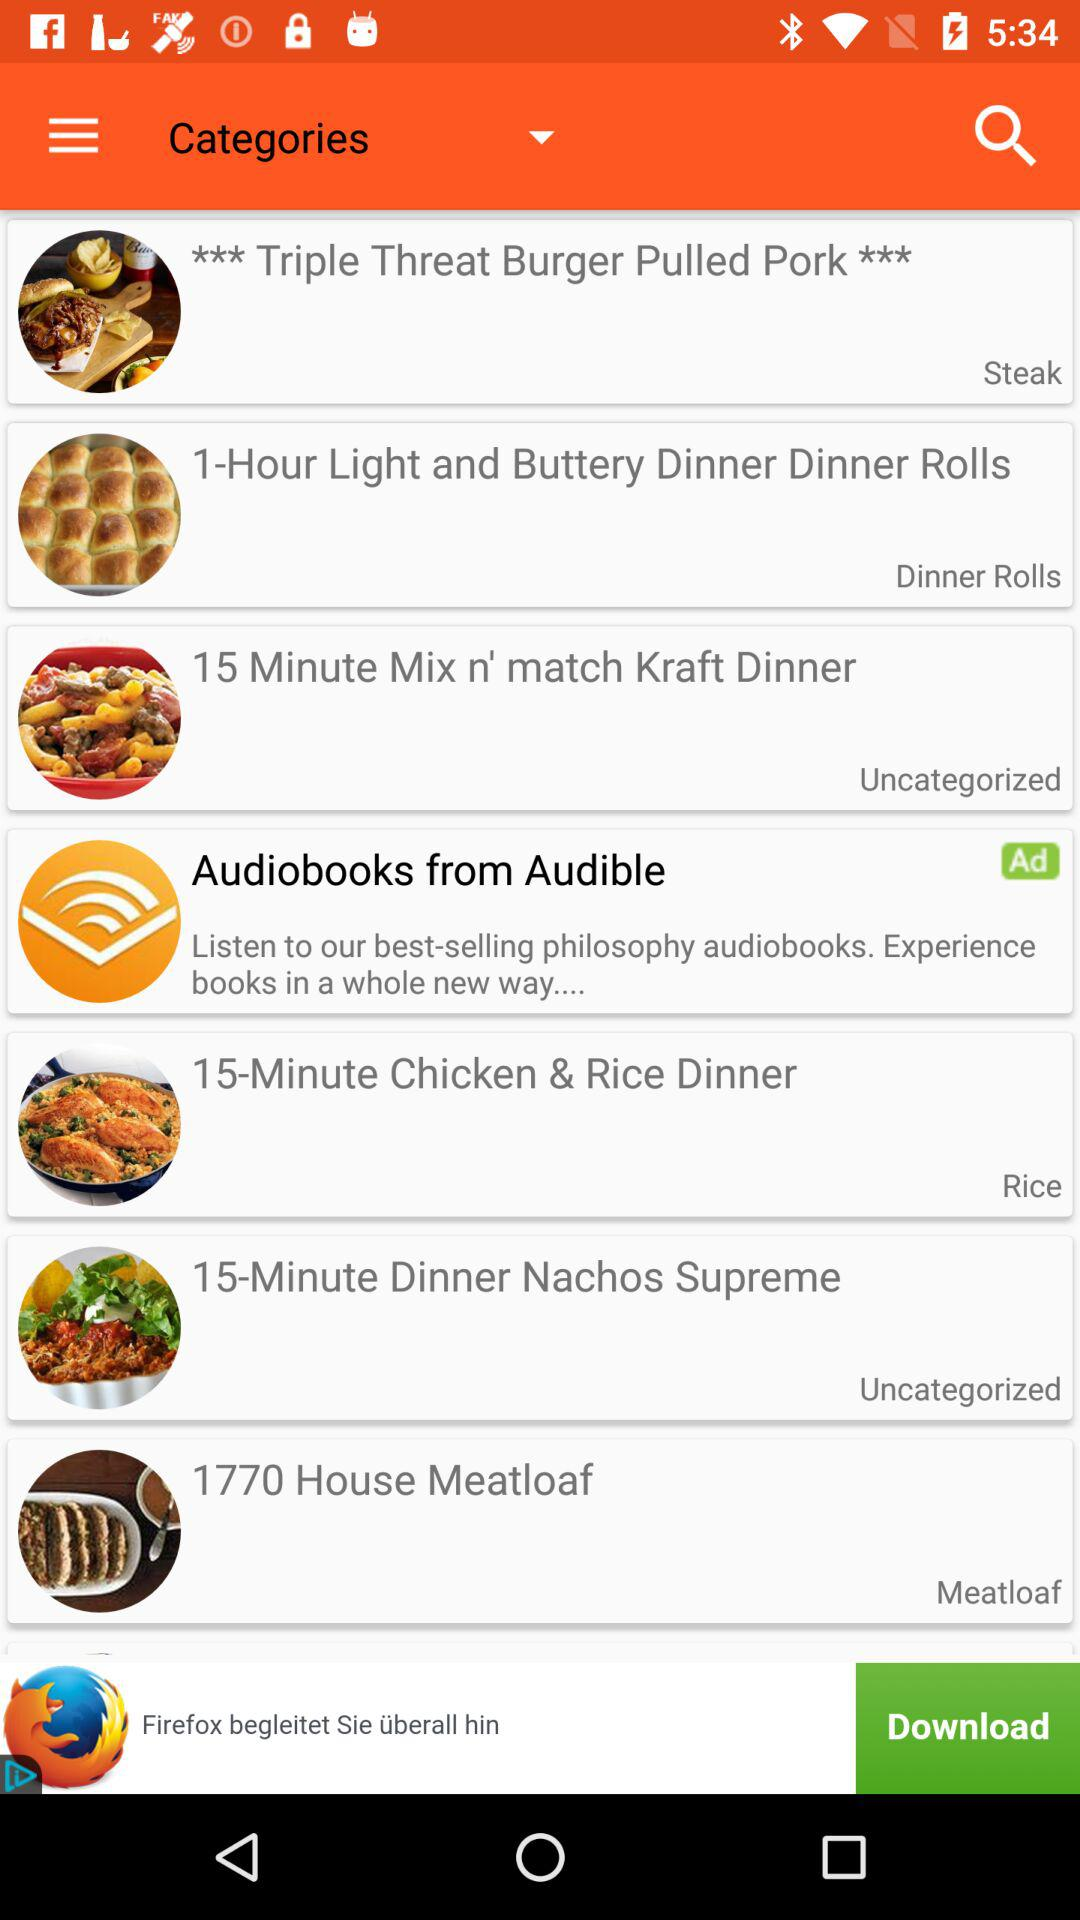What's the name of the dish in the meatloaf category? The name of the dish is 1770 House Meatloaf. 